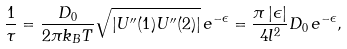Convert formula to latex. <formula><loc_0><loc_0><loc_500><loc_500>\frac { 1 } { \tau } = \frac { D _ { 0 } } { 2 \pi k _ { B } T } \sqrt { \left | U ^ { \prime \prime } ( 1 ) U ^ { \prime \prime } ( 2 ) \right | } \, e ^ { - \epsilon } = \frac { \pi \left | \epsilon \right | } { 4 l ^ { 2 } } D _ { 0 } \, e ^ { - \epsilon } ,</formula> 